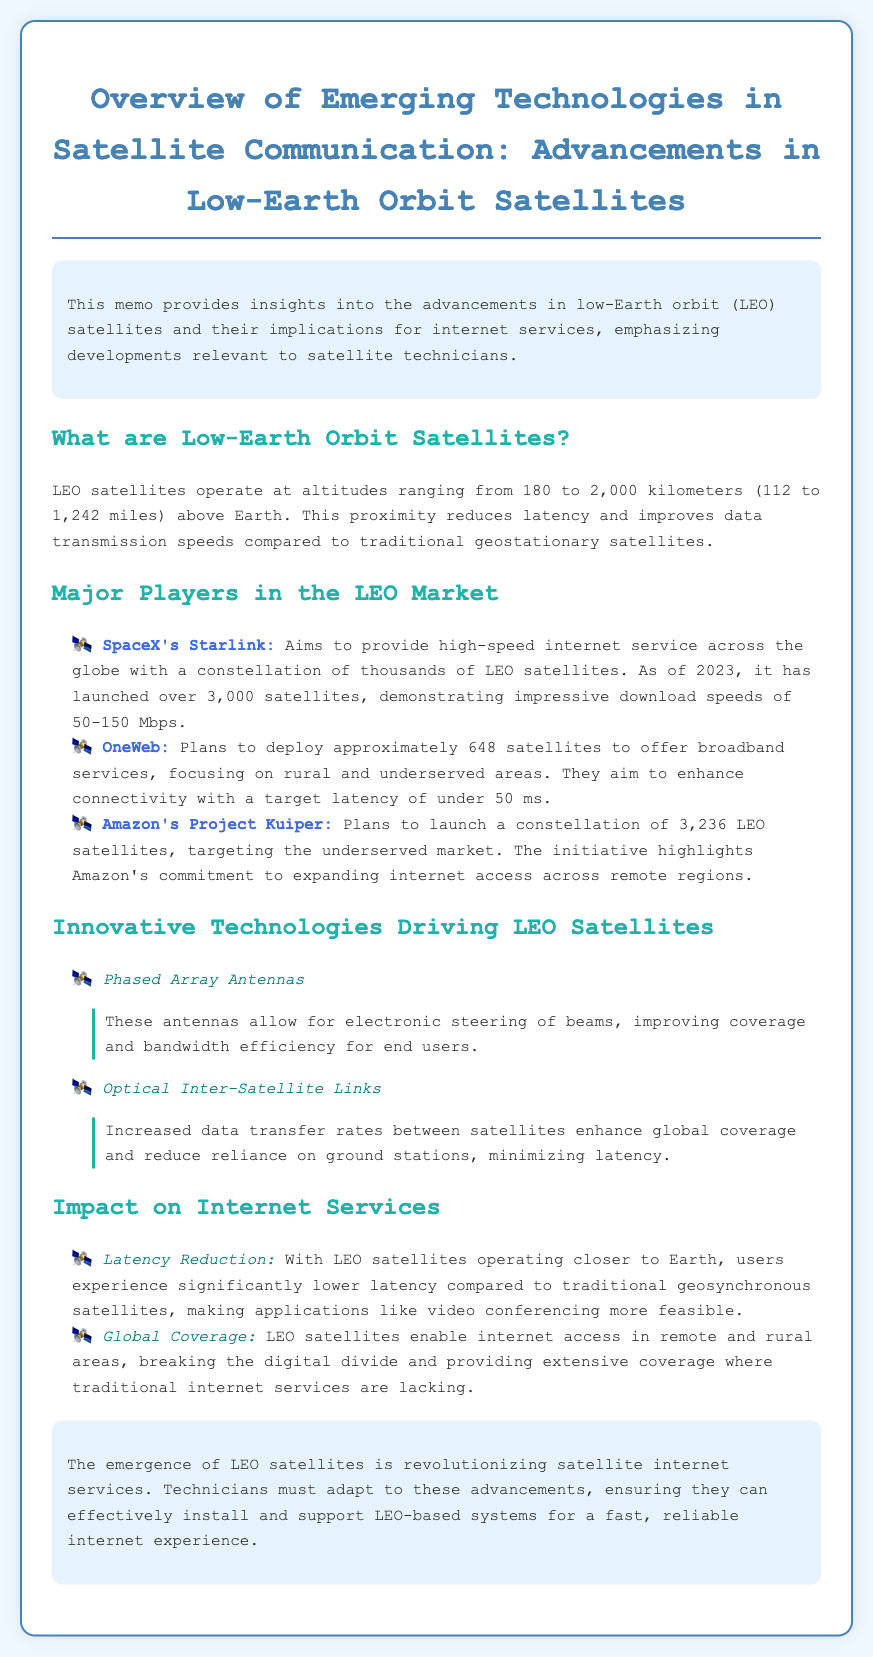What is the altitude range for LEO satellites? LEO satellites operate at altitudes ranging from 180 to 2,000 kilometers above Earth.
Answer: 180 to 2,000 kilometers How many satellites has SpaceX's Starlink launched as of 2023? SpaceX's Starlink has launched over 3,000 satellites as of 2023.
Answer: over 3,000 satellites What latency target does OneWeb aim for? OneWeb aims for a target latency of under 50 ms.
Answer: under 50 ms What innovative technology improves coverage and bandwidth efficiency? Phased Array Antennas improve coverage and bandwidth efficiency.
Answer: Phased Array Antennas How does the operation of LEO satellites affect latency for users? Users experience significantly lower latency with LEO satellites compared to traditional geosynchronous satellites.
Answer: significantly lower latency What is the total number of satellites planned by Amazon's Project Kuiper? Amazon's Project Kuiper plans to launch a constellation of 3,236 LEO satellites.
Answer: 3,236 LEO satellites What major benefit do LEO satellites provide in terms of internet access? LEO satellites enable internet access in remote and rural areas.
Answer: internet access in remote and rural areas What must technicians do in response to the emergence of LEO satellites? Technicians must adapt to these advancements to support LEO-based systems.
Answer: adapt to these advancements 